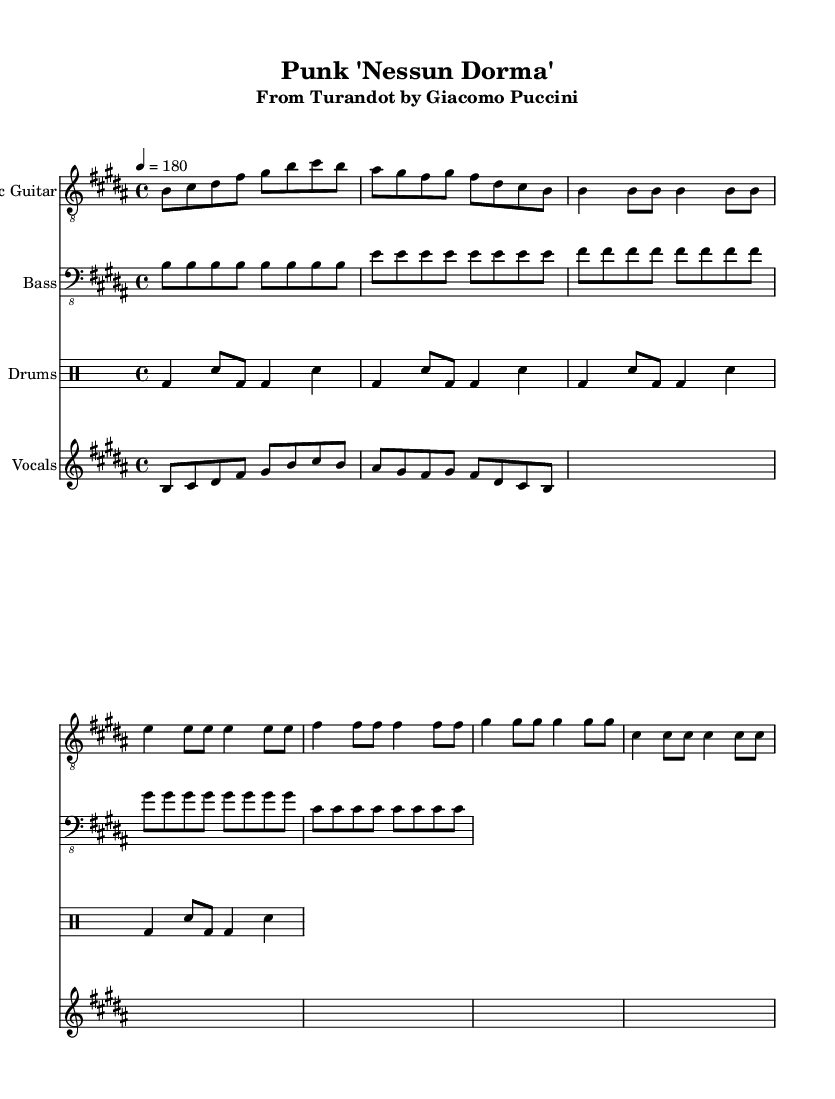What is the key signature of this music? The key signature has five sharps indicated, which means it is B major. Every sharp aligns with the lines and spaces of the staff depending on the note.
Answer: B major What is the time signature of this music? The time signature shown at the beginning of the score is 4/4, which means there are four beats in each measure and the quarter note gets one beat. This can be seen directly in the notation at the start.
Answer: 4/4 What is the tempo marking of the piece? The tempo marking indicates a speed of 180 beats per minute, specified as "4 = 180" in the score. This shows how fast the piece should be played.
Answer: 180 How many measures are there in the electric guitar part? By counting the grouped notes and observing the bar lines, there are a total of 8 measures in the electric guitar part. Each bar line demarcates the end of a measure.
Answer: 8 measures Which musical style does this arrangement reinterpret? The arrangement reinterprets the opera aria "Nessun Dorma" from Puccini's Turandot into a punk style, as indicated by the title and the heavy instrumentation typical of punk music.
Answer: Punk What instruments are featured in the arrangement? The score includes an electric guitar, bass guitar, drums, and vocals, as specified in the headers for each respective instrument in the score.
Answer: Electric guitar, bass guitar, drums, vocals What is the rhythmic pattern used in the drum part? The drumming pattern alternates between bass drum and snare with a consistent rhythm for a punk style, as seen in the repeated drum notation which maintains a driving rhythm characteristic of punk.
Answer: Bass and snare pattern 